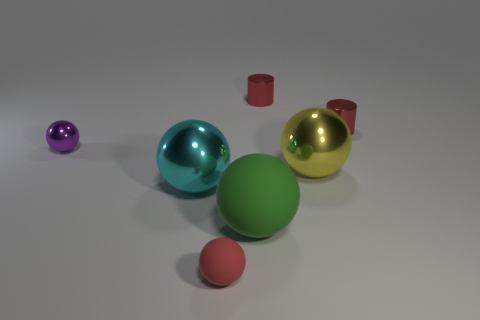Subtract all big yellow metal spheres. How many spheres are left? 4 Subtract all purple spheres. How many spheres are left? 4 Add 1 purple shiny blocks. How many objects exist? 8 Subtract all gray balls. Subtract all red cylinders. How many balls are left? 5 Subtract all spheres. How many objects are left? 2 Subtract 1 cyan balls. How many objects are left? 6 Subtract all small purple balls. Subtract all tiny objects. How many objects are left? 2 Add 2 red rubber balls. How many red rubber balls are left? 3 Add 7 small brown rubber things. How many small brown rubber things exist? 7 